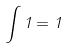<formula> <loc_0><loc_0><loc_500><loc_500>\int 1 = 1</formula> 